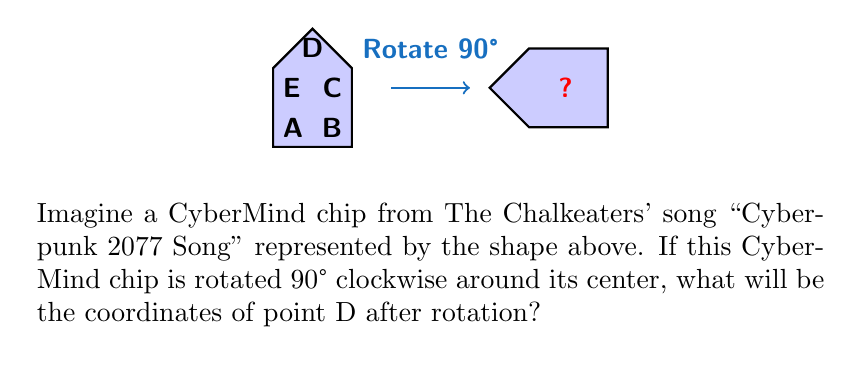Can you answer this question? Let's approach this step-by-step:

1) First, we need to identify the center of rotation. The center of the shape is approximately at (0.5, 0.75).

2) The original coordinates of point D are (0.5, 1.5).

3) To rotate a point (x, y) by 90° clockwise around the origin, we use the formula:
   $$(x', y') = (y, -x)$$

4) However, we're rotating around (0.5, 0.75), not (0, 0). So we need to:
   a) Translate the point to make (0.5, 0.75) the origin
   b) Rotate
   c) Translate back

5) Let's do these steps:
   a) Translate: (0.5, 1.5) → (0, 0.75)
   b) Rotate 90° clockwise: (0, 0.75) → (0.75, 0)
   c) Translate back: (0.75, 0) → (1.25, 0.75)

6) Therefore, after rotation, point D will be at (1.25, 0.75).

7) We can verify this visually: D was at the top of the shape before rotation, so it should be at the right side of the shape after a 90° clockwise rotation.
Answer: (1.25, 0.75) 